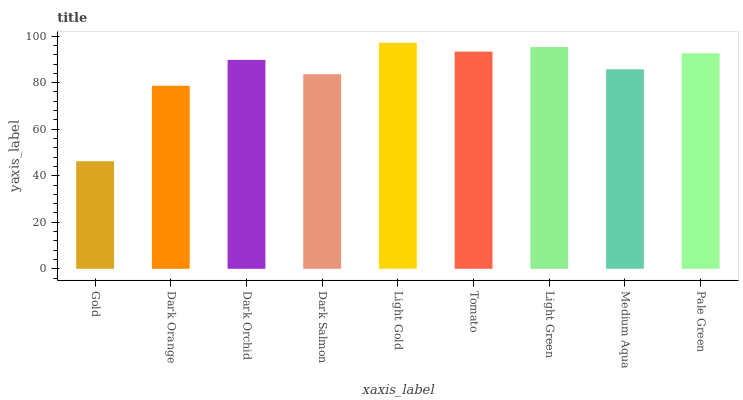Is Gold the minimum?
Answer yes or no. Yes. Is Light Gold the maximum?
Answer yes or no. Yes. Is Dark Orange the minimum?
Answer yes or no. No. Is Dark Orange the maximum?
Answer yes or no. No. Is Dark Orange greater than Gold?
Answer yes or no. Yes. Is Gold less than Dark Orange?
Answer yes or no. Yes. Is Gold greater than Dark Orange?
Answer yes or no. No. Is Dark Orange less than Gold?
Answer yes or no. No. Is Dark Orchid the high median?
Answer yes or no. Yes. Is Dark Orchid the low median?
Answer yes or no. Yes. Is Gold the high median?
Answer yes or no. No. Is Gold the low median?
Answer yes or no. No. 